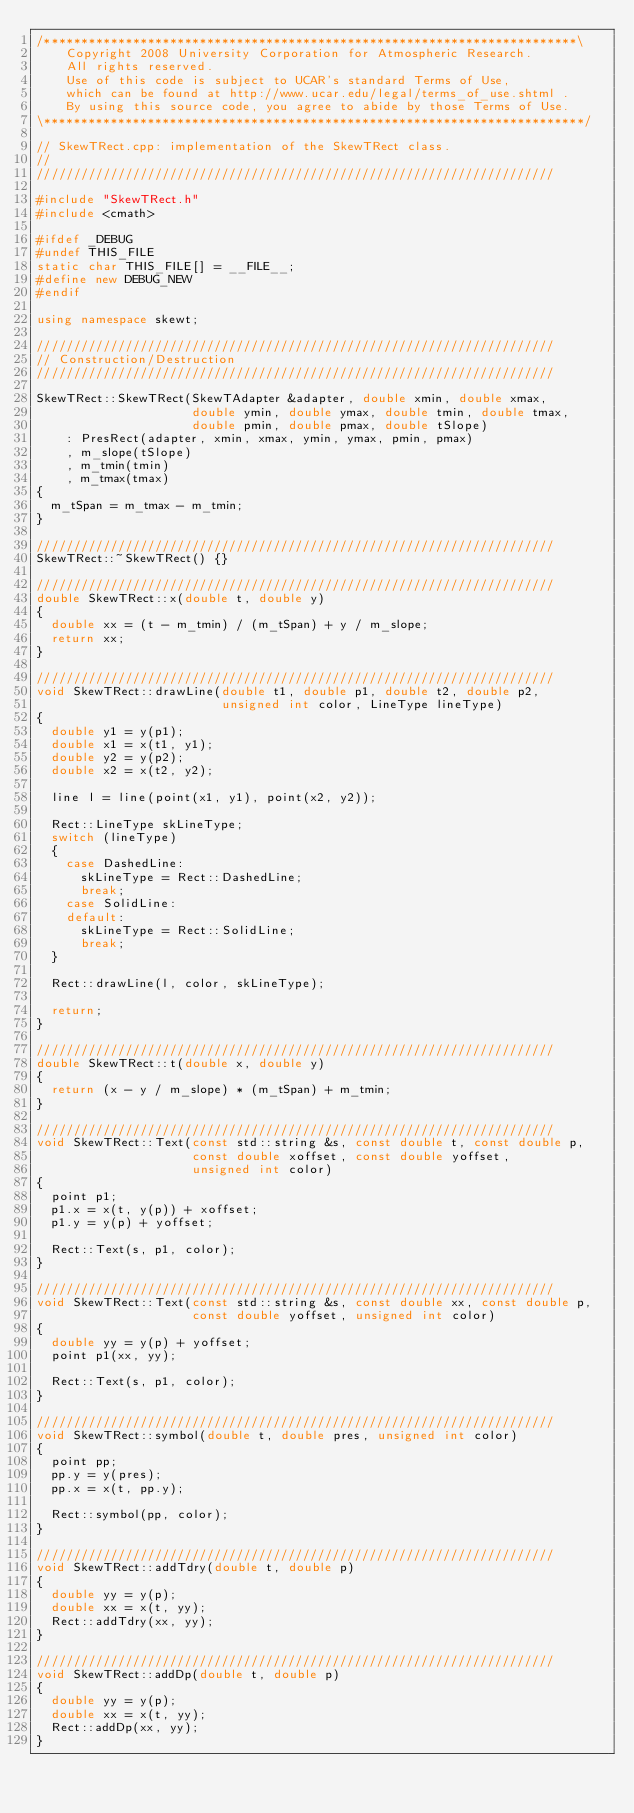Convert code to text. <code><loc_0><loc_0><loc_500><loc_500><_C++_>/************************************************************************\
    Copyright 2008 University Corporation for Atmospheric Research.
    All rights reserved.
    Use of this code is subject to UCAR's standard Terms of Use,
    which can be found at http://www.ucar.edu/legal/terms_of_use.shtml .
    By using this source code, you agree to abide by those Terms of Use.
\*************************************************************************/

// SkewTRect.cpp: implementation of the SkewTRect class.
//
//////////////////////////////////////////////////////////////////////

#include "SkewTRect.h"
#include <cmath>

#ifdef _DEBUG
#undef THIS_FILE
static char THIS_FILE[] = __FILE__;
#define new DEBUG_NEW
#endif

using namespace skewt;

//////////////////////////////////////////////////////////////////////
// Construction/Destruction
//////////////////////////////////////////////////////////////////////

SkewTRect::SkewTRect(SkewTAdapter &adapter, double xmin, double xmax,
                     double ymin, double ymax, double tmin, double tmax,
                     double pmin, double pmax, double tSlope)
    : PresRect(adapter, xmin, xmax, ymin, ymax, pmin, pmax)
    , m_slope(tSlope)
    , m_tmin(tmin)
    , m_tmax(tmax)
{
  m_tSpan = m_tmax - m_tmin;
}

//////////////////////////////////////////////////////////////////////
SkewTRect::~SkewTRect() {}

//////////////////////////////////////////////////////////////////////
double SkewTRect::x(double t, double y)
{
  double xx = (t - m_tmin) / (m_tSpan) + y / m_slope;
  return xx;
}

//////////////////////////////////////////////////////////////////////
void SkewTRect::drawLine(double t1, double p1, double t2, double p2,
                         unsigned int color, LineType lineType)
{
  double y1 = y(p1);
  double x1 = x(t1, y1);
  double y2 = y(p2);
  double x2 = x(t2, y2);

  line l = line(point(x1, y1), point(x2, y2));

  Rect::LineType skLineType;
  switch (lineType)
  {
    case DashedLine:
      skLineType = Rect::DashedLine;
      break;
    case SolidLine:
    default:
      skLineType = Rect::SolidLine;
      break;
  }

  Rect::drawLine(l, color, skLineType);

  return;
}

//////////////////////////////////////////////////////////////////////
double SkewTRect::t(double x, double y)
{
  return (x - y / m_slope) * (m_tSpan) + m_tmin;
}

//////////////////////////////////////////////////////////////////////
void SkewTRect::Text(const std::string &s, const double t, const double p,
                     const double xoffset, const double yoffset,
                     unsigned int color)
{
  point p1;
  p1.x = x(t, y(p)) + xoffset;
  p1.y = y(p) + yoffset;

  Rect::Text(s, p1, color);
}

//////////////////////////////////////////////////////////////////////
void SkewTRect::Text(const std::string &s, const double xx, const double p,
                     const double yoffset, unsigned int color)
{
  double yy = y(p) + yoffset;
  point p1(xx, yy);

  Rect::Text(s, p1, color);
}

//////////////////////////////////////////////////////////////////////
void SkewTRect::symbol(double t, double pres, unsigned int color)
{
  point pp;
  pp.y = y(pres);
  pp.x = x(t, pp.y);

  Rect::symbol(pp, color);
}

//////////////////////////////////////////////////////////////////////
void SkewTRect::addTdry(double t, double p)
{
  double yy = y(p);
  double xx = x(t, yy);
  Rect::addTdry(xx, yy);
}

//////////////////////////////////////////////////////////////////////
void SkewTRect::addDp(double t, double p)
{
  double yy = y(p);
  double xx = x(t, yy);
  Rect::addDp(xx, yy);
}
</code> 